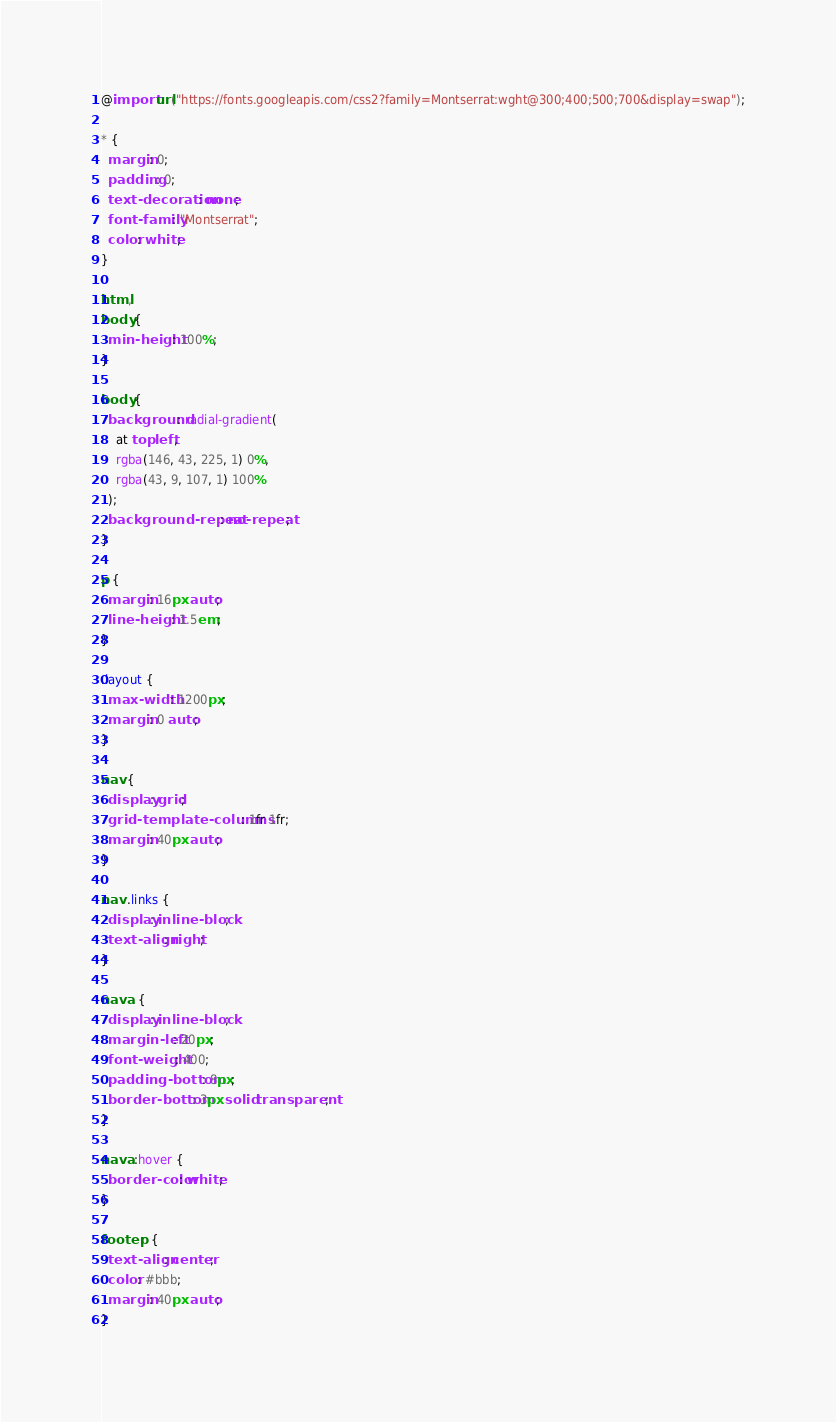<code> <loc_0><loc_0><loc_500><loc_500><_CSS_>@import url("https://fonts.googleapis.com/css2?family=Montserrat:wght@300;400;500;700&display=swap");

* {
  margin: 0;
  padding: 0;
  text-decoration: none;
  font-family: "Montserrat";
  color: white;
}

html,
body {
  min-height: 100%;
}

body {
  background: radial-gradient(
    at top left,
    rgba(146, 43, 225, 1) 0%,
    rgba(43, 9, 107, 1) 100%
  );
  background-repeat: no-repeat;
}

p {
  margin: 16px auto;
  line-height: 1.5em;
}

.layout {
  max-width: 1200px;
  margin: 0 auto;
}

nav {
  display: grid;
  grid-template-columns: 1fr 1fr;
  margin: 40px auto;
}

nav .links {
  display: inline-block;
  text-align: right;
}

nav a {
  display: inline-block;
  margin-left: 20px;
  font-weight: 400;
  padding-bottom: 8px;
  border-bottom: 3px solid transparent;
}

nav a:hover {
  border-color: white;
}

footer p {
  text-align: center;
  color: #bbb;
  margin: 40px auto;
}
</code> 